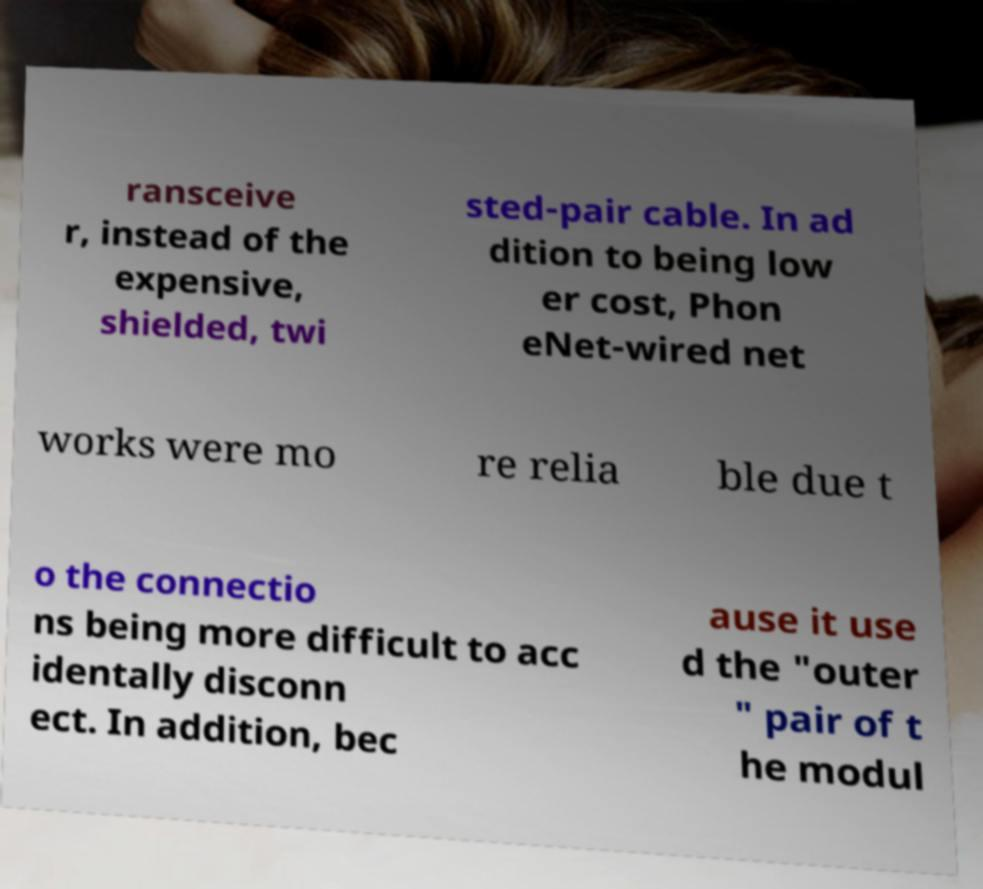Could you assist in decoding the text presented in this image and type it out clearly? ransceive r, instead of the expensive, shielded, twi sted-pair cable. In ad dition to being low er cost, Phon eNet-wired net works were mo re relia ble due t o the connectio ns being more difficult to acc identally disconn ect. In addition, bec ause it use d the "outer " pair of t he modul 